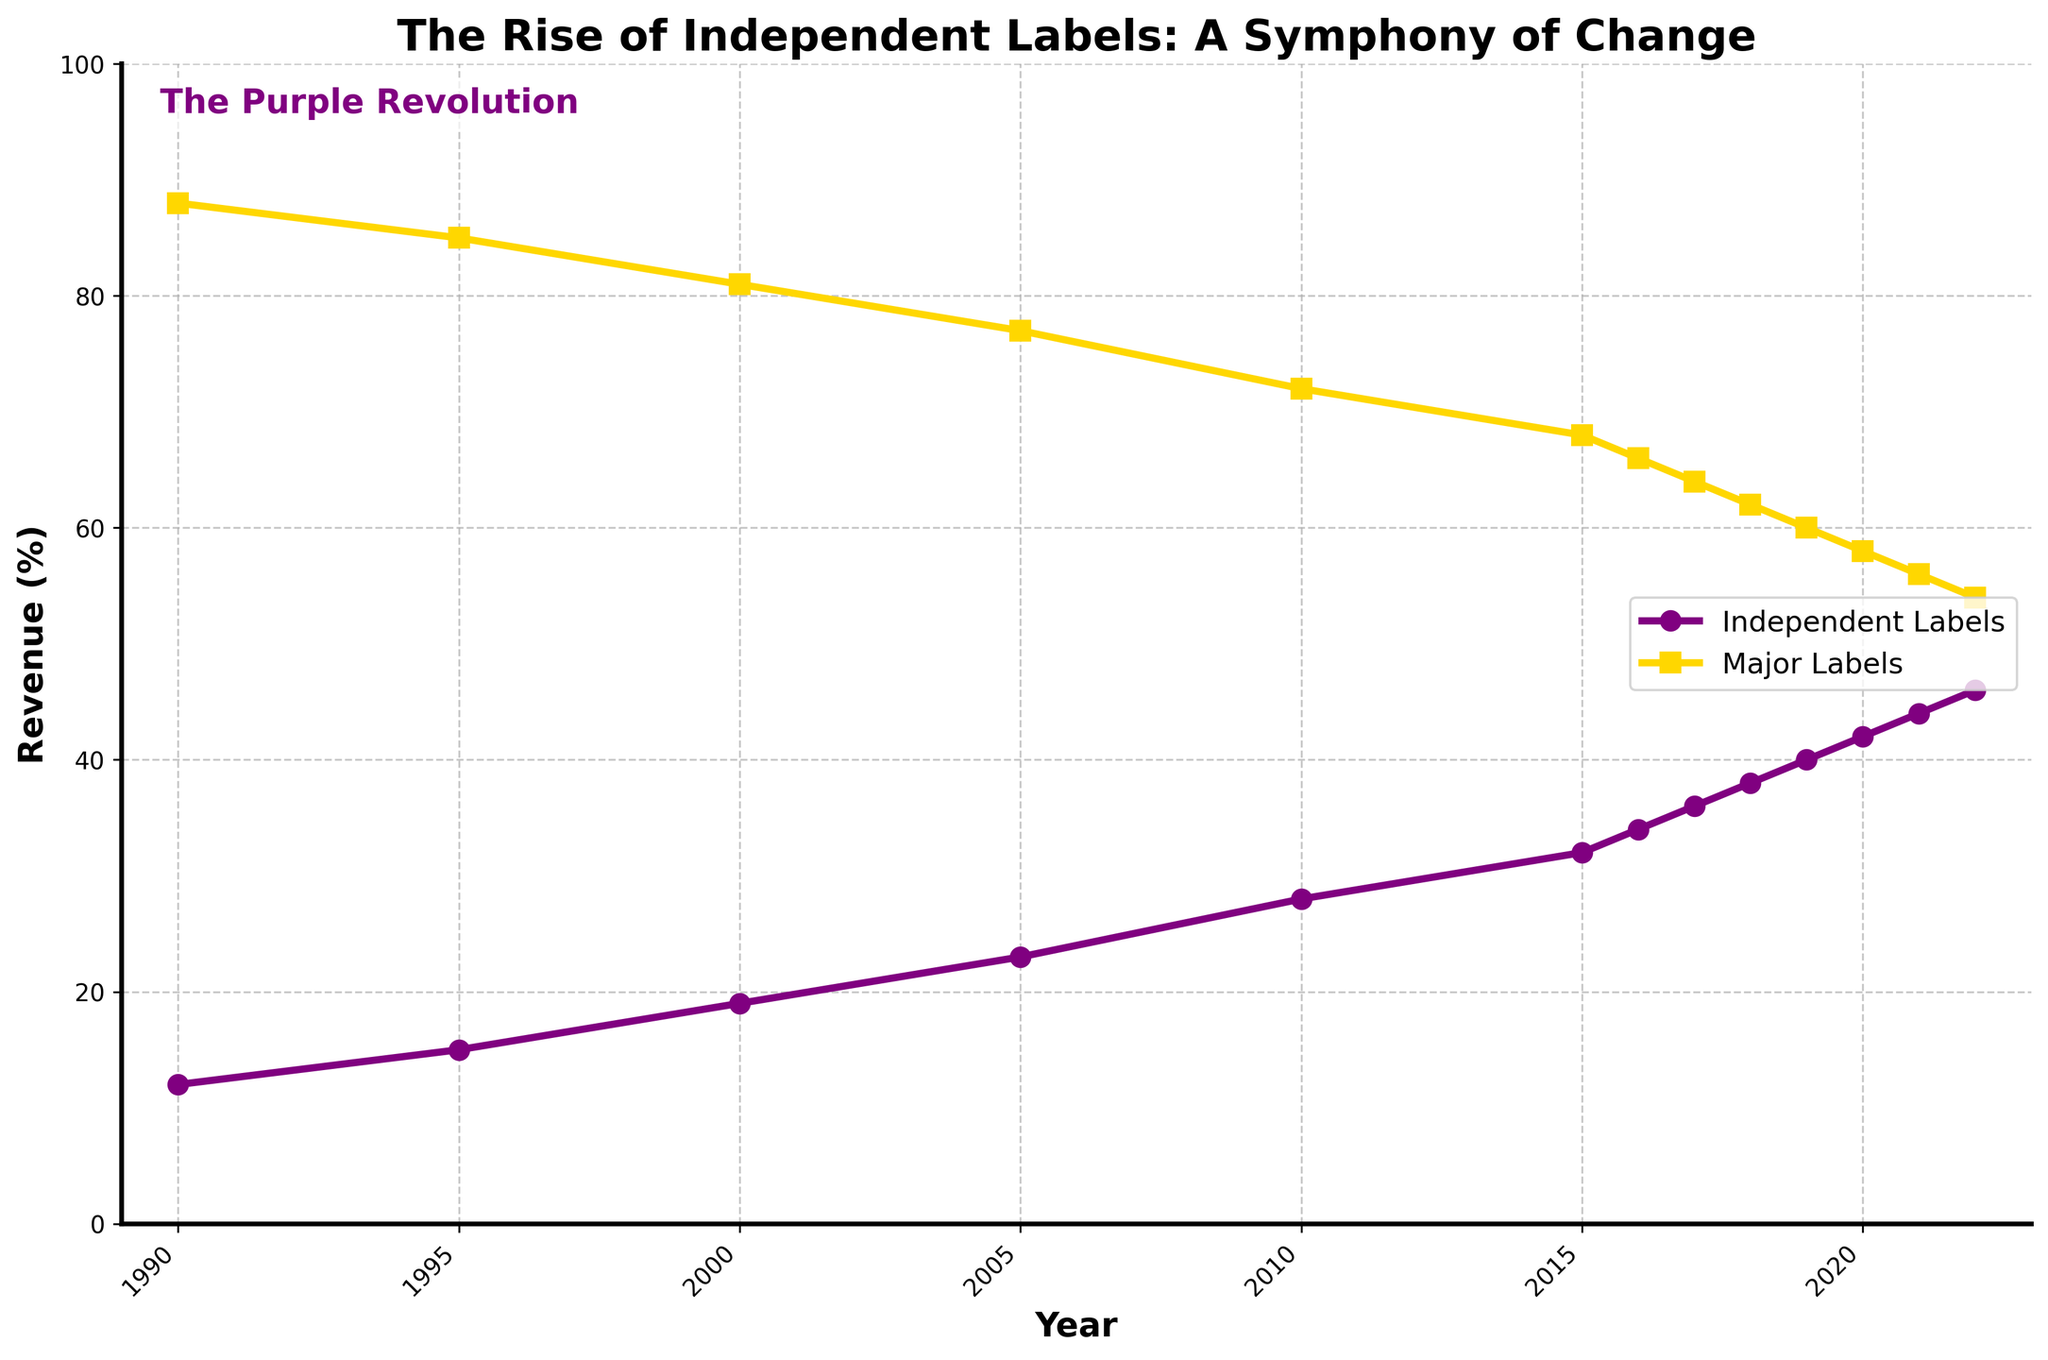What year did Independent Labels and Major Labels have the smallest revenue percentage difference? Identify the smallest gap by comparing the differences for each year: 1990 (88-12=76%), 1995 (85-15=70%), 2000 (81-19=62%), 2005 (77-23=54%), 2010 (72-28=44%), 2015 (68-32=36%), 2016 (66-34=32%), 2017 (64-36=28%), 2018 (62-38=24%), 2019 (60-40=20%), 2020 (58-42=16%), 2021 (56-44=12%), 2022 (54-46=8%). The smallest difference is 8% in 2022.
Answer: 2022 In what year did Independent Labels' revenue percentage reach 30% or higher for the first time? Look at the "Independent Labels Revenue (%)" series and find the first year where the value is 30% or above. The data shows 2015 at 32%.
Answer: 2015 What was the percentage increase in revenue for Independent Labels from 1990 to 2022? Calculate the increase by subtracting the 1990 value from the 2022 value: 46% (2022) - 12% (1990) = 34%.
Answer: 34% Between which consecutive years did Major Labels see the highest decrease in revenue percentage? Calculate the decrease for each pair of consecutive years: 1990-1995 (88-85=3%), 1995-2000 (85-81=4%), 2000-2005 (81-77=4%), 2005-2010 (77-72=5%), 2010-2015 (72-68=4%), 2015-2016 (68-66=2%), 2016-2017 (66-64=2%), 2017-2018 (64-62=2%), 2018-2019 (62-60=2%), 2019-2020 (60-58=2%), 2020-2021 (58-56=2%), 2021-2022 (56-54=2%). The highest decrease is 5% between 2005 and 2010.
Answer: 2005 to 2010 What visual element indicates the trend line for Independent Labels? Look at the chart and identify the visual characteristic used for the Independent Labels series. The Independent Labels trend line is marked with circles and is purple in color.
Answer: Purple line with circles In what period did Independent Labels surpass 40% revenue percentage, and by how much did it surpass this threshold? Look at the data for the first year where the Independent Labels percentage is above 40%, which is 2019 at 40%, and 2020 is 42%. Therefore, in 2020, it surpassed the 40% threshold by 2%.
Answer: 2020 by 2% What is the trend of Major Labels' revenue percentage from 2015 to 2022? Observe the values for Major Labels during the period: 2015 (68%), 2016 (66%), 2017 (64%), 2018 (62%), 2019 (60%), 2020 (58%), 2021 (56%), 2022 (54%). The trend shows a steady decrease from 68% to 54%.
Answer: Steady decrease What does the text "The Purple Revolution" signify in the context of this plot? Interpret the contextual relevance of the text. "The Purple Revolution" likely refers to the significant rise of Independent Labels (marked in purple) as a powerful trend opposing the dominance of Major Labels.
Answer: Rise of Independent Labels When did Major Labels' revenue percentage fall below 60%? Find the first year when Major Labels' revenue percentage is less than 60%. This milestone is reached in 2020 (58%).
Answer: 2020 